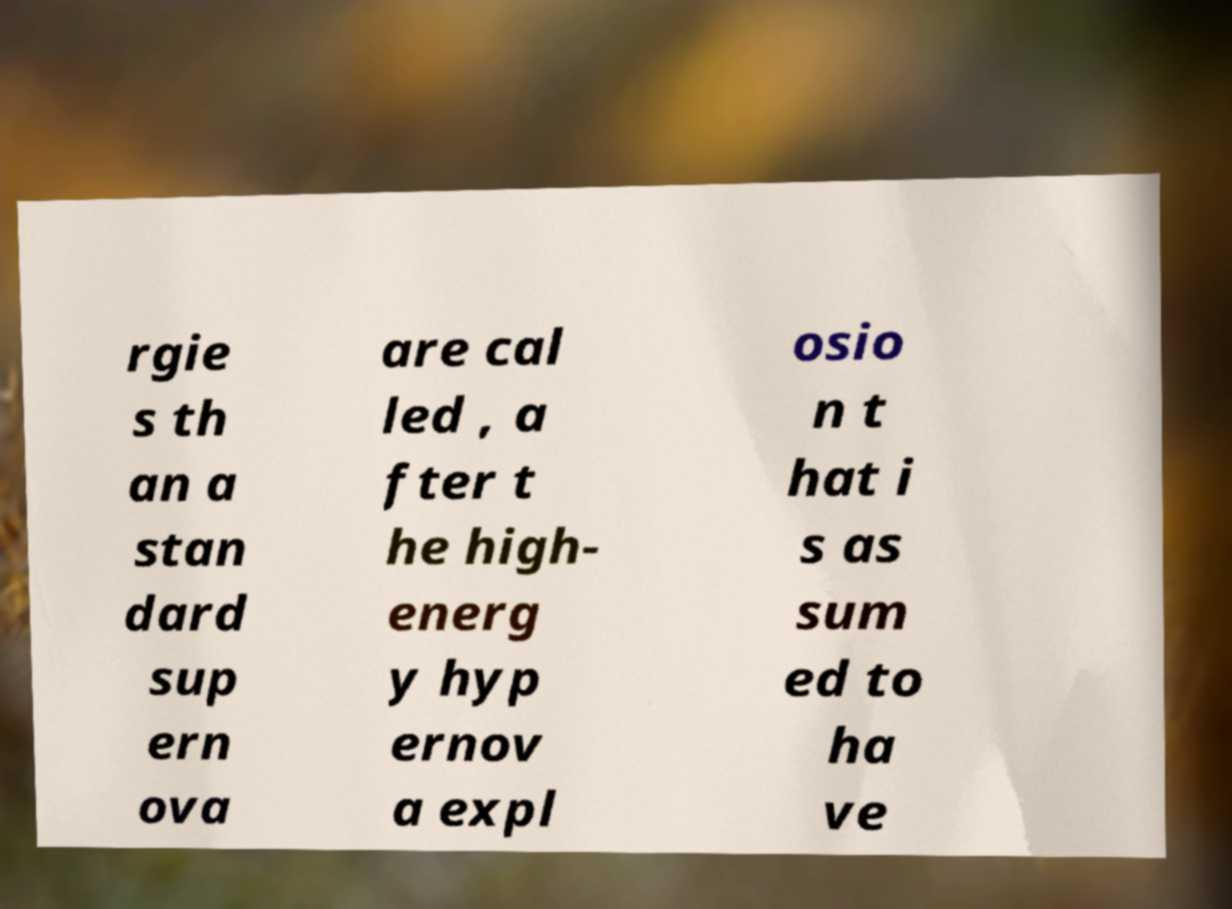What messages or text are displayed in this image? I need them in a readable, typed format. rgie s th an a stan dard sup ern ova are cal led , a fter t he high- energ y hyp ernov a expl osio n t hat i s as sum ed to ha ve 